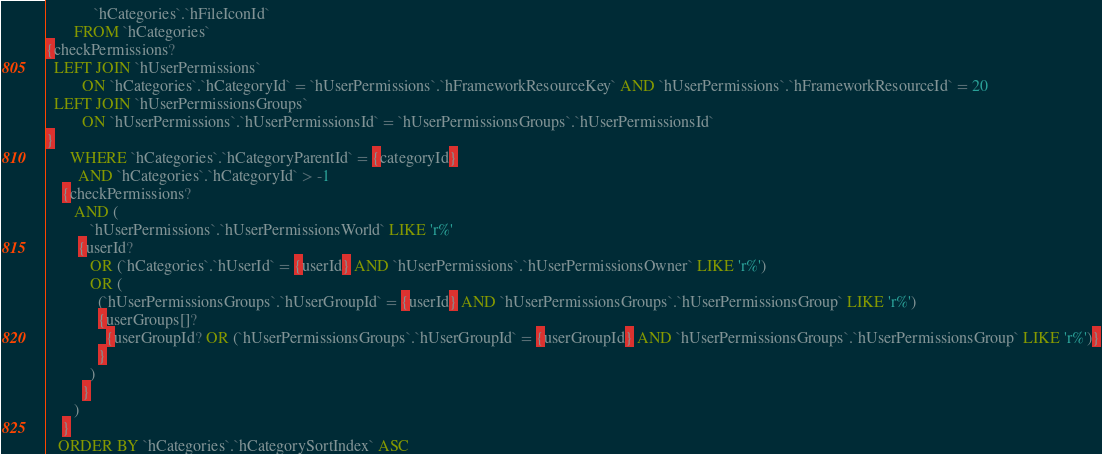Convert code to text. <code><loc_0><loc_0><loc_500><loc_500><_SQL_>            `hCategories`.`hFileIconId`
       FROM `hCategories`
{checkPermissions?
  LEFT JOIN `hUserPermissions`
         ON `hCategories`.`hCategoryId` = `hUserPermissions`.`hFrameworkResourceKey` AND `hUserPermissions`.`hFrameworkResourceId` = 20
  LEFT JOIN `hUserPermissionsGroups`
         ON `hUserPermissions`.`hUserPermissionsId` = `hUserPermissionsGroups`.`hUserPermissionsId`
}
      WHERE `hCategories`.`hCategoryParentId` = {categoryId}
        AND `hCategories`.`hCategoryId` > -1
    {checkPermissions?
       AND (
           `hUserPermissions`.`hUserPermissionsWorld` LIKE 'r%'
        {userId?
           OR (`hCategories`.`hUserId` = {userId} AND `hUserPermissions`.`hUserPermissionsOwner` LIKE 'r%')
           OR (
             (`hUserPermissionsGroups`.`hUserGroupId` = {userId} AND `hUserPermissionsGroups`.`hUserPermissionsGroup` LIKE 'r%')
             {userGroups[]?
               {userGroupId? OR (`hUserPermissionsGroups`.`hUserGroupId` = {userGroupId} AND `hUserPermissionsGroups`.`hUserPermissionsGroup` LIKE 'r%')}
             }
           )
         }
       )
    }
   ORDER BY `hCategories`.`hCategorySortIndex` ASC
</code> 